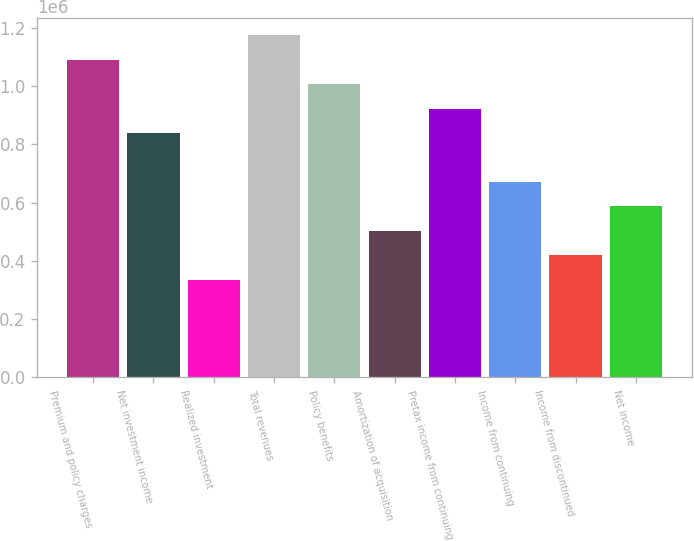<chart> <loc_0><loc_0><loc_500><loc_500><bar_chart><fcel>Premium and policy charges<fcel>Net investment income<fcel>Realized investment<fcel>Total revenues<fcel>Policy benefits<fcel>Amortization of acquisition<fcel>Pretax income from continuing<fcel>Income from continuing<fcel>Income from discontinued<fcel>Net income<nl><fcel>1.09055e+06<fcel>838888<fcel>335555<fcel>1.17444e+06<fcel>1.00667e+06<fcel>503333<fcel>922777<fcel>671110<fcel>419444<fcel>587222<nl></chart> 